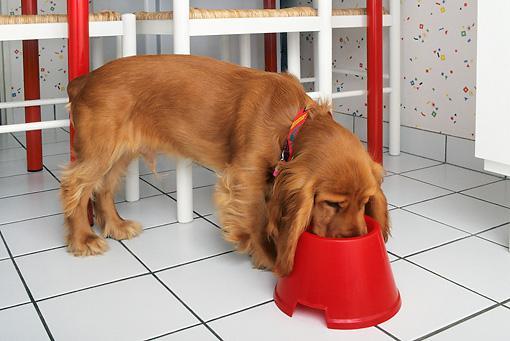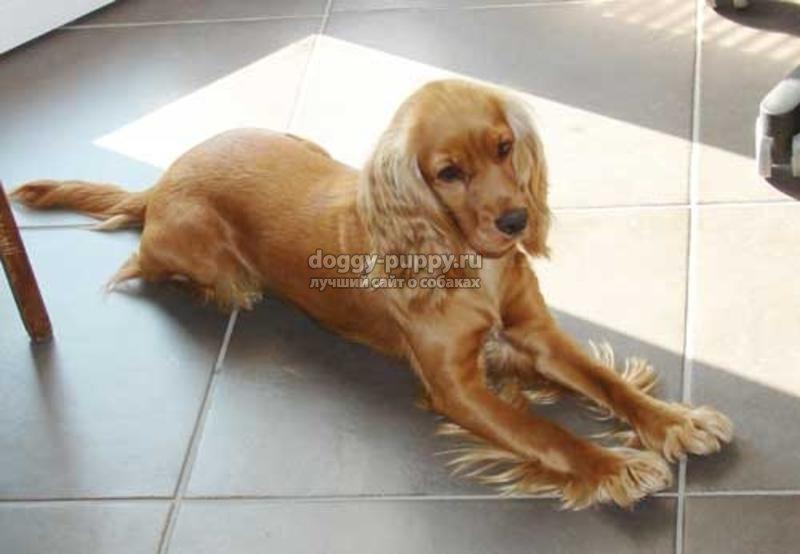The first image is the image on the left, the second image is the image on the right. Evaluate the accuracy of this statement regarding the images: "An image includes an orange cocker spaniel with its nose in a dog bowl without a patterned design.". Is it true? Answer yes or no. Yes. The first image is the image on the left, the second image is the image on the right. Analyze the images presented: Is the assertion "The dog in the image on the left is eating out of a bowl." valid? Answer yes or no. Yes. 